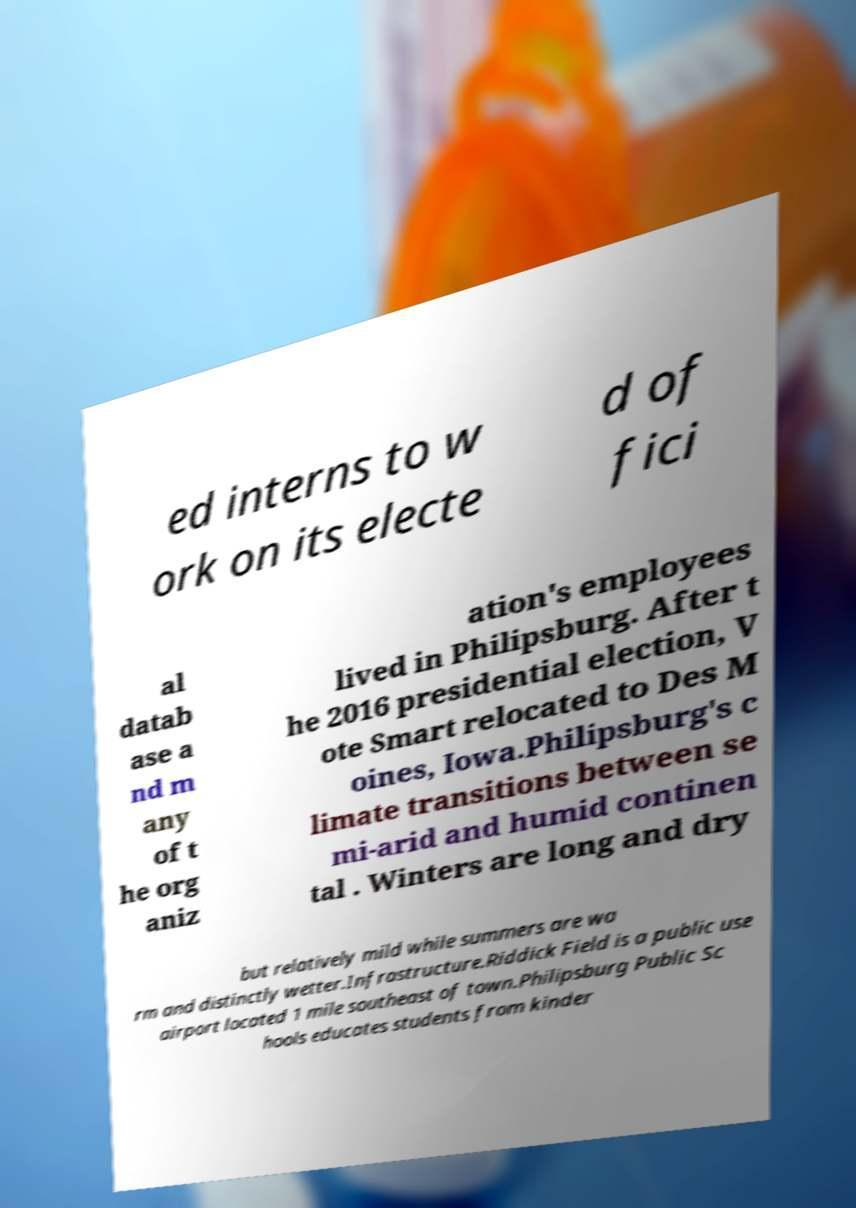Can you read and provide the text displayed in the image?This photo seems to have some interesting text. Can you extract and type it out for me? ed interns to w ork on its electe d of fici al datab ase a nd m any of t he org aniz ation's employees lived in Philipsburg. After t he 2016 presidential election, V ote Smart relocated to Des M oines, Iowa.Philipsburg's c limate transitions between se mi-arid and humid continen tal . Winters are long and dry but relatively mild while summers are wa rm and distinctly wetter.Infrastructure.Riddick Field is a public use airport located 1 mile southeast of town.Philipsburg Public Sc hools educates students from kinder 